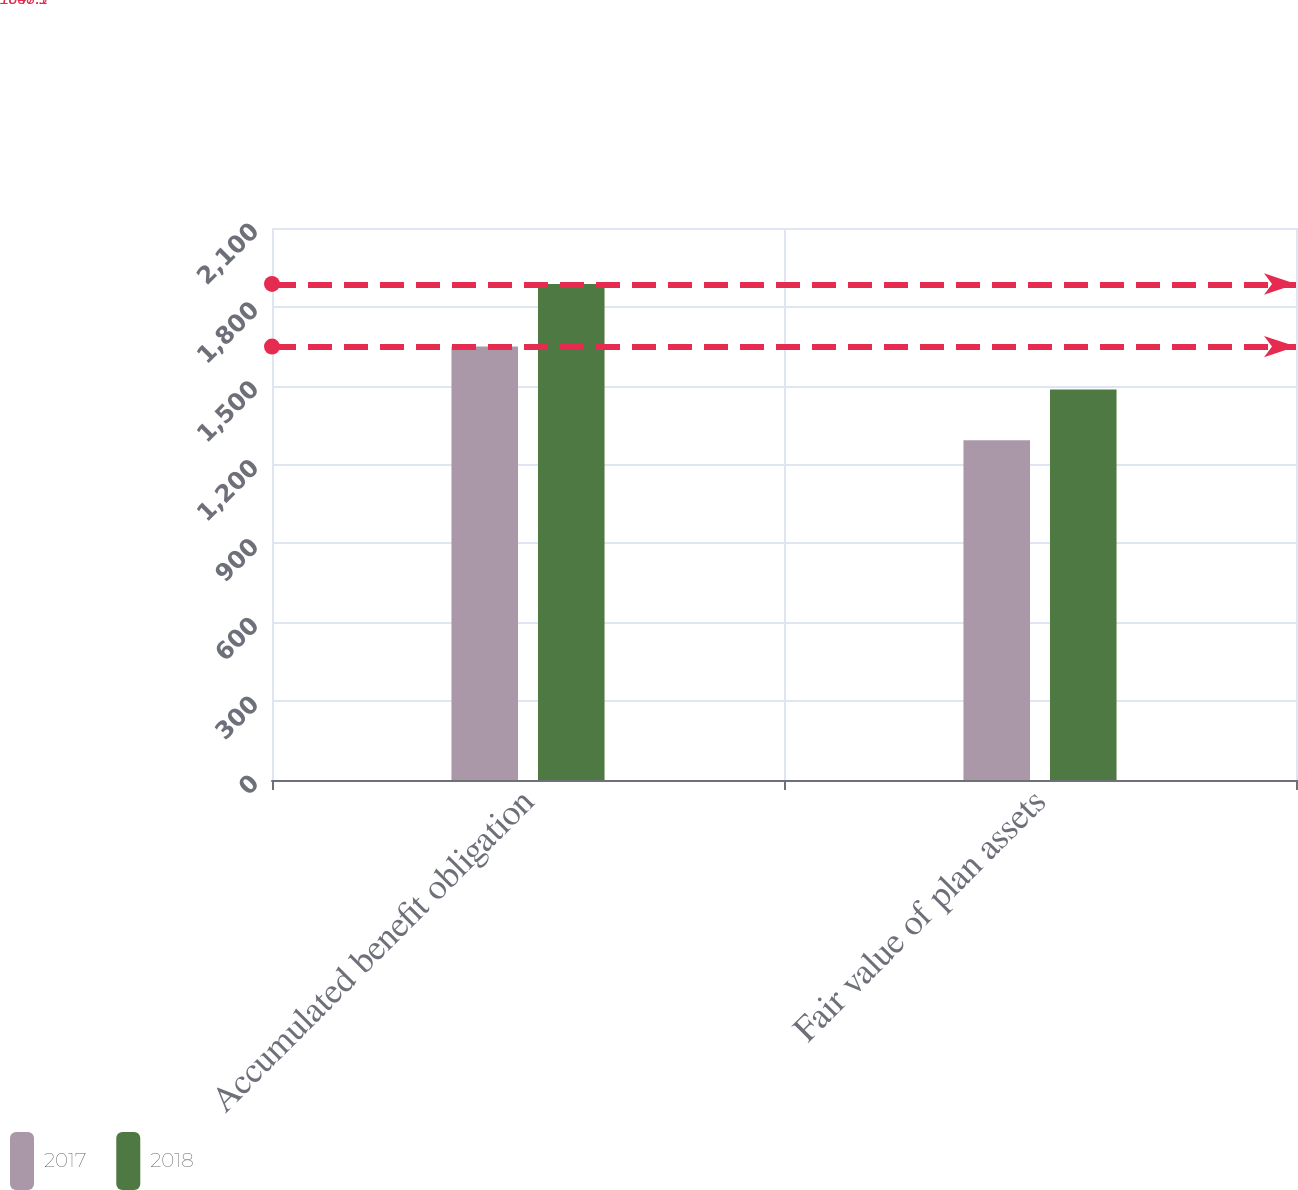<chart> <loc_0><loc_0><loc_500><loc_500><stacked_bar_chart><ecel><fcel>Accumulated benefit obligation<fcel>Fair value of plan assets<nl><fcel>2017<fcel>1648.9<fcel>1292.6<nl><fcel>2018<fcel>1887.1<fcel>1485.2<nl></chart> 